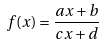Convert formula to latex. <formula><loc_0><loc_0><loc_500><loc_500>f ( x ) = \frac { a x + b } { c x + d }</formula> 